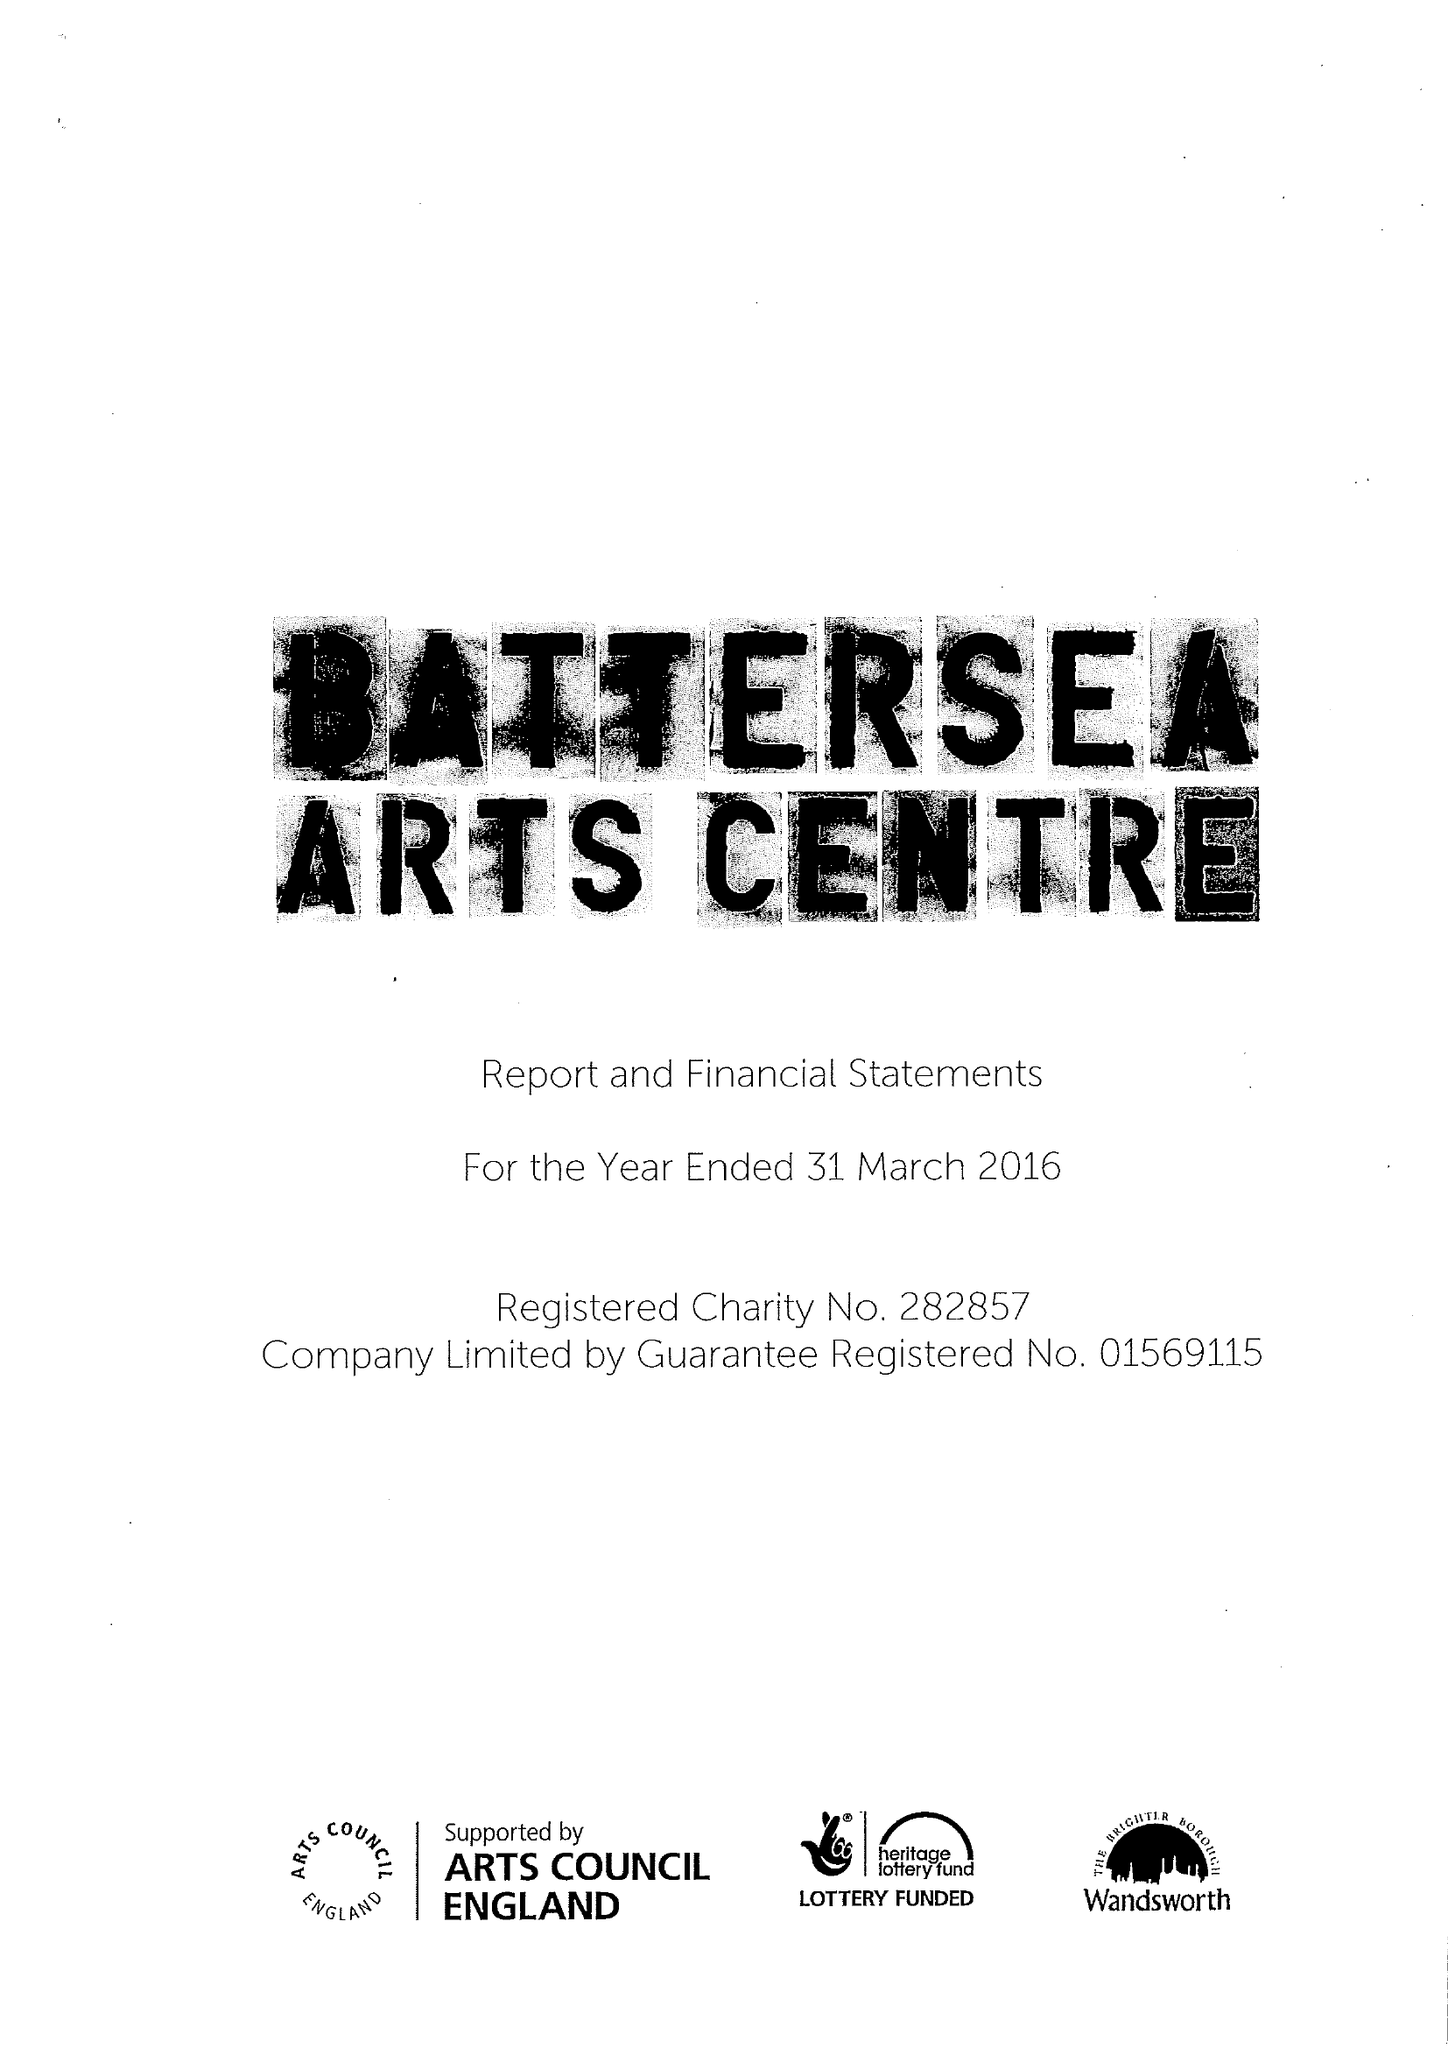What is the value for the address__post_town?
Answer the question using a single word or phrase. LONDON 